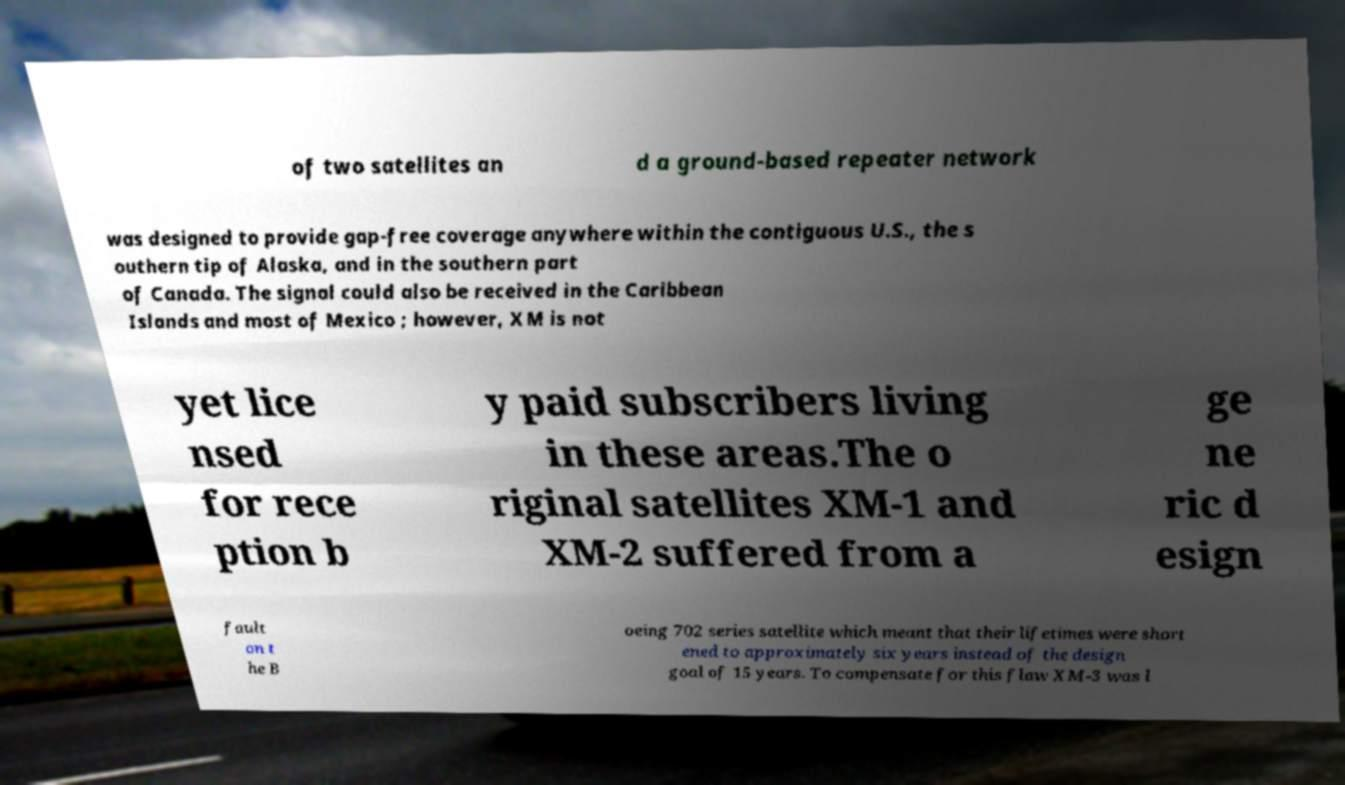Can you accurately transcribe the text from the provided image for me? of two satellites an d a ground-based repeater network was designed to provide gap-free coverage anywhere within the contiguous U.S., the s outhern tip of Alaska, and in the southern part of Canada. The signal could also be received in the Caribbean Islands and most of Mexico ; however, XM is not yet lice nsed for rece ption b y paid subscribers living in these areas.The o riginal satellites XM-1 and XM-2 suffered from a ge ne ric d esign fault on t he B oeing 702 series satellite which meant that their lifetimes were short ened to approximately six years instead of the design goal of 15 years. To compensate for this flaw XM-3 was l 